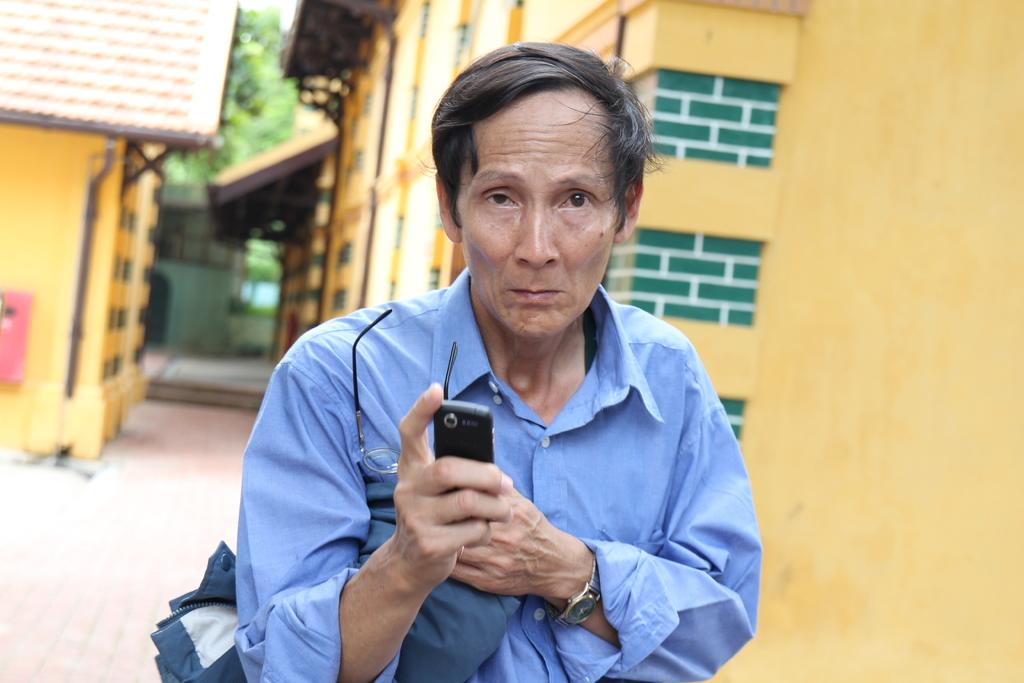Who is present in the image? There is a man in the image. What is the man holding in the image? The man is holding a mobile and spectacles. What can be seen in the background of the image? There is a wall, a building, a road, and trees in the image. What is the man's tendency to walk towards the sea in the image? There is no sea present in the image, so it is not possible to determine the man's tendency to walk towards it. 